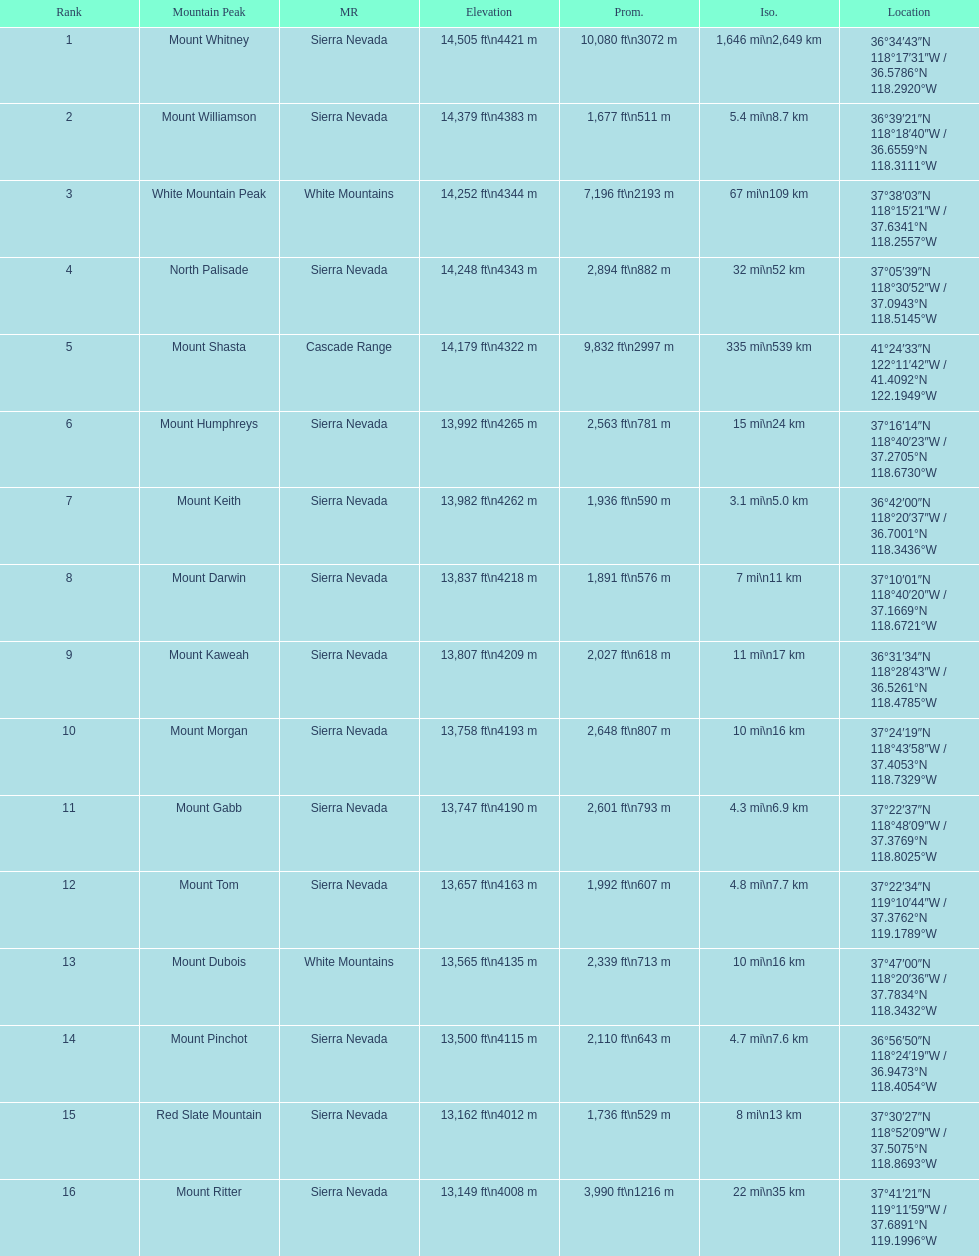What is the only mountain peak listed for the cascade range? Mount Shasta. 